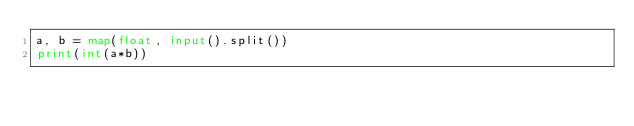<code> <loc_0><loc_0><loc_500><loc_500><_Python_>a, b = map(float, input().split())
print(int(a*b))</code> 